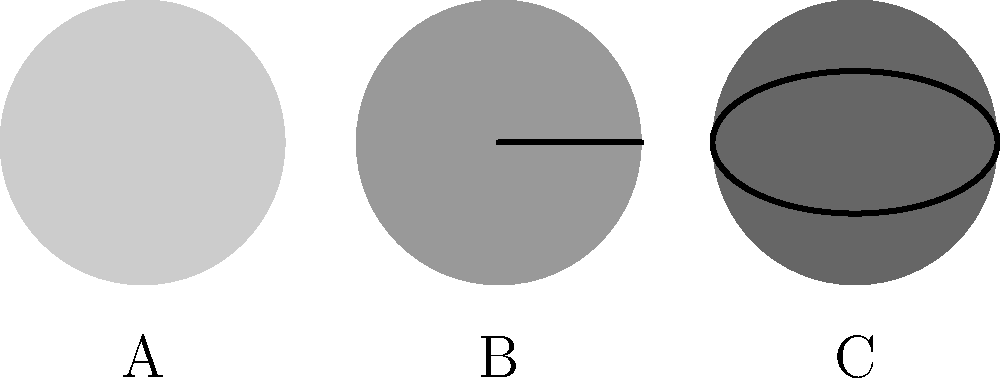As a database administrator managing large datasets for AI models, you're tasked with organizing galaxy classification data. The diagram shows simplified representations of three galaxy types: elliptical (A), spiral (B), and lenticular (C). Which of these galaxy types is typically associated with older stellar populations and less active star formation? To answer this question, let's analyze each galaxy type step-by-step:

1. Galaxy A (Elliptical):
   - Represented by a simple circular shape
   - Elliptical galaxies are characterized by:
     a) Smooth, featureless appearance
     b) Little to no gas and dust
     c) Predominantly older, redder stars
     d) Low rate of star formation

2. Galaxy B (Spiral):
   - Represented by a circular shape with a line through it (indicating spiral arms)
   - Spiral galaxies are characterized by:
     a) Distinct spiral arms
     b) Presence of gas and dust
     c) Mix of young and old stars
     d) Active star formation in the arms

3. Galaxy C (Lenticular):
   - Represented by an elliptical shape
   - Lenticular galaxies are intermediate between elliptical and spiral:
     a) Disk-like structure but no spiral arms
     b) Little gas and dust
     c) Predominantly older stars
     d) Low rate of star formation

Among these three types, elliptical galaxies (Type A) are most strongly associated with older stellar populations and less active star formation. This is due to their lack of gas and dust, which are necessary for forming new stars. The smooth, featureless appearance is a result of the absence of star-forming regions and the predominance of older, redder stars.
Answer: Elliptical (Type A) 